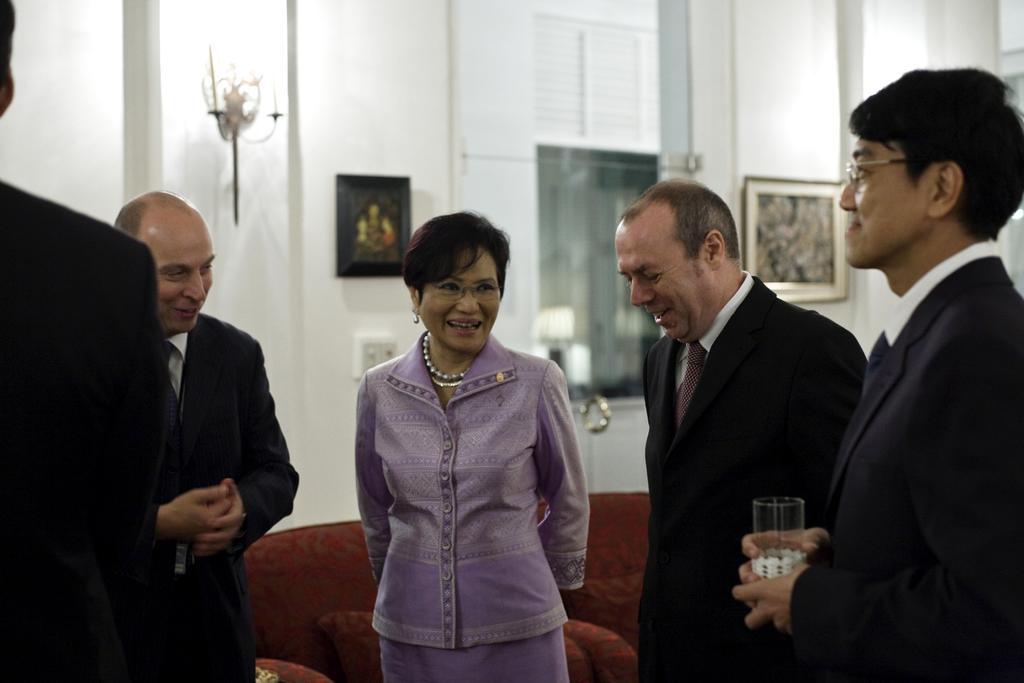How would you summarize this image in a sentence or two? In this image there are five persons standing, towards the left of the image there is a person truncated, towards the right of the image there is a person holding a glass, there is a sofa behind the person, there is a wall behind the persons, there is a photo frame on the wall, there is a light, there is a window. 